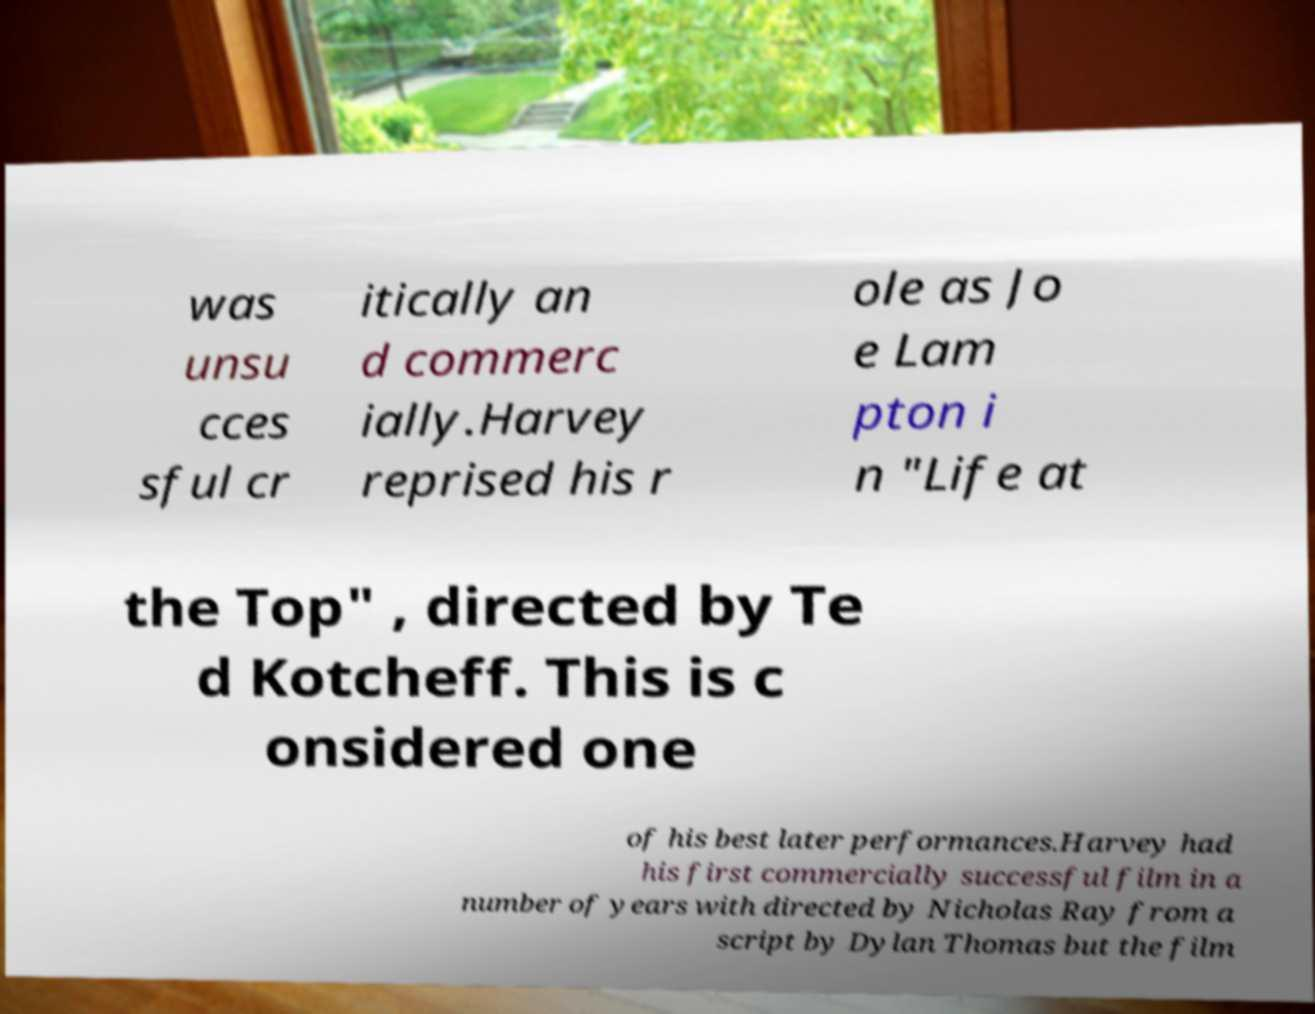Could you extract and type out the text from this image? was unsu cces sful cr itically an d commerc ially.Harvey reprised his r ole as Jo e Lam pton i n "Life at the Top" , directed by Te d Kotcheff. This is c onsidered one of his best later performances.Harvey had his first commercially successful film in a number of years with directed by Nicholas Ray from a script by Dylan Thomas but the film 